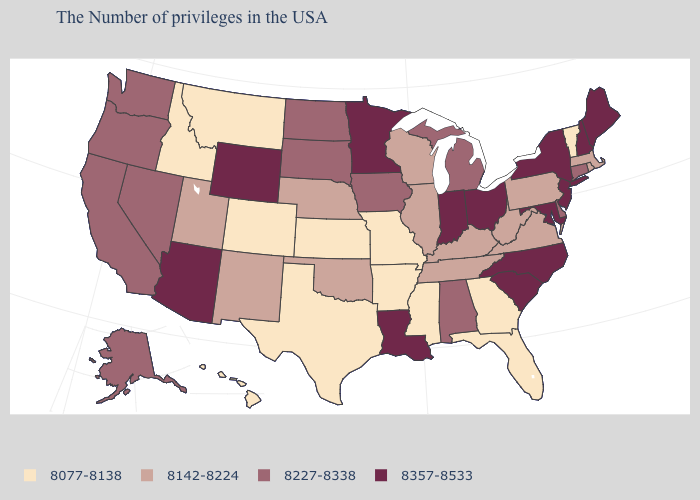How many symbols are there in the legend?
Short answer required. 4. Name the states that have a value in the range 8077-8138?
Answer briefly. Vermont, Florida, Georgia, Mississippi, Missouri, Arkansas, Kansas, Texas, Colorado, Montana, Idaho, Hawaii. Among the states that border Virginia , does West Virginia have the lowest value?
Give a very brief answer. Yes. Name the states that have a value in the range 8077-8138?
Write a very short answer. Vermont, Florida, Georgia, Mississippi, Missouri, Arkansas, Kansas, Texas, Colorado, Montana, Idaho, Hawaii. Name the states that have a value in the range 8357-8533?
Write a very short answer. Maine, New Hampshire, New York, New Jersey, Maryland, North Carolina, South Carolina, Ohio, Indiana, Louisiana, Minnesota, Wyoming, Arizona. Is the legend a continuous bar?
Answer briefly. No. Among the states that border Michigan , does Ohio have the highest value?
Write a very short answer. Yes. What is the value of Vermont?
Give a very brief answer. 8077-8138. Which states have the lowest value in the USA?
Short answer required. Vermont, Florida, Georgia, Mississippi, Missouri, Arkansas, Kansas, Texas, Colorado, Montana, Idaho, Hawaii. Which states hav the highest value in the MidWest?
Short answer required. Ohio, Indiana, Minnesota. Which states have the highest value in the USA?
Give a very brief answer. Maine, New Hampshire, New York, New Jersey, Maryland, North Carolina, South Carolina, Ohio, Indiana, Louisiana, Minnesota, Wyoming, Arizona. What is the highest value in the USA?
Be succinct. 8357-8533. What is the highest value in the West ?
Concise answer only. 8357-8533. What is the value of Kansas?
Concise answer only. 8077-8138. 